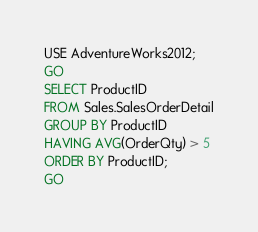<code> <loc_0><loc_0><loc_500><loc_500><_SQL_>USE AdventureWorks2012;
GO
SELECT ProductID 
FROM Sales.SalesOrderDetail
GROUP BY ProductID
HAVING AVG(OrderQty) > 5
ORDER BY ProductID;
GO</code> 